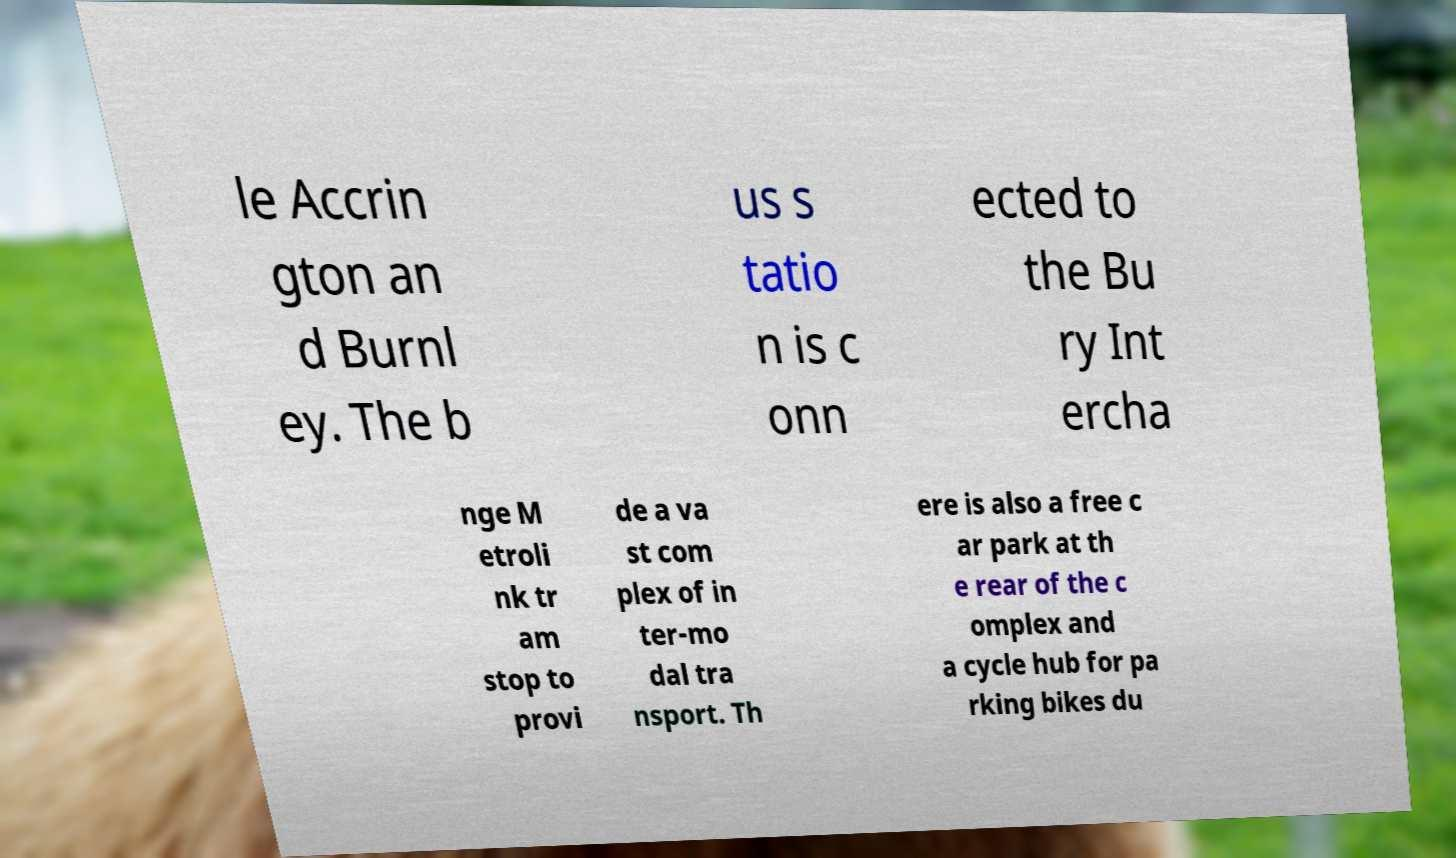Can you read and provide the text displayed in the image?This photo seems to have some interesting text. Can you extract and type it out for me? le Accrin gton an d Burnl ey. The b us s tatio n is c onn ected to the Bu ry Int ercha nge M etroli nk tr am stop to provi de a va st com plex of in ter-mo dal tra nsport. Th ere is also a free c ar park at th e rear of the c omplex and a cycle hub for pa rking bikes du 